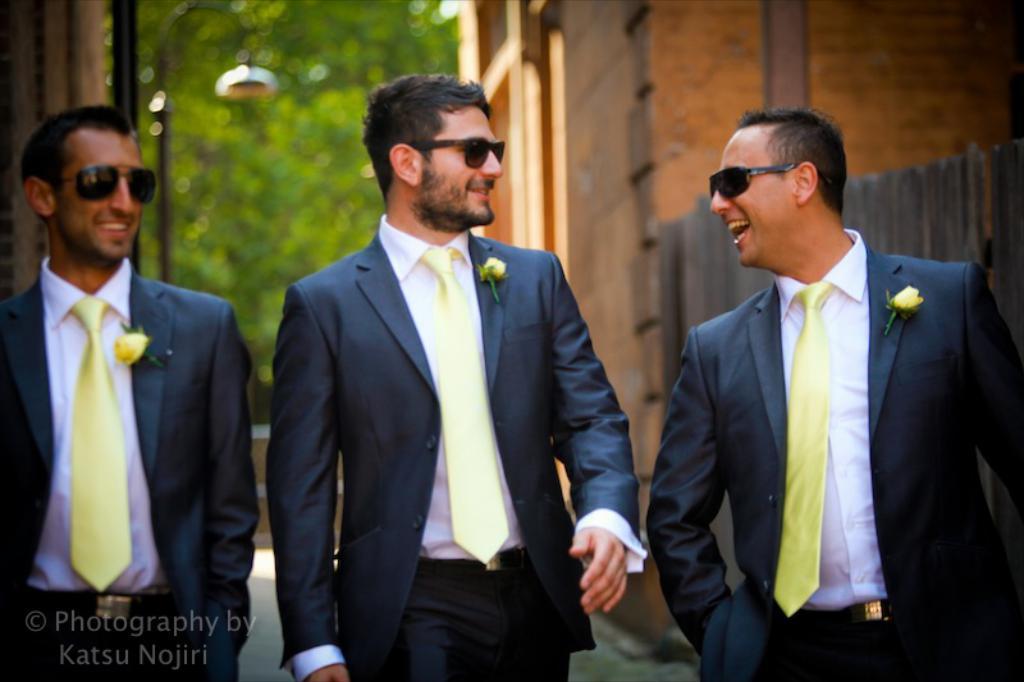Please provide a concise description of this image. In this image there are three persons. They are wearing suit, tie and goggles. Behind the them there are two buildings. In between the building there is a tree. Before the building there is a street light. 